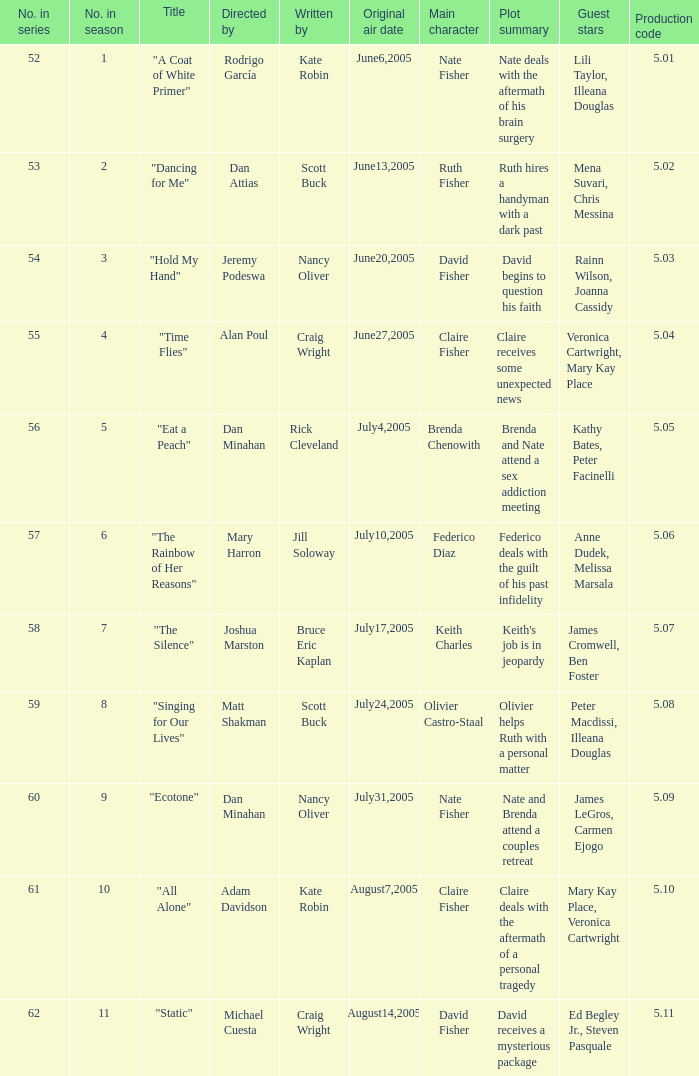What date was episode 10 in the season originally aired? August7,2005. 